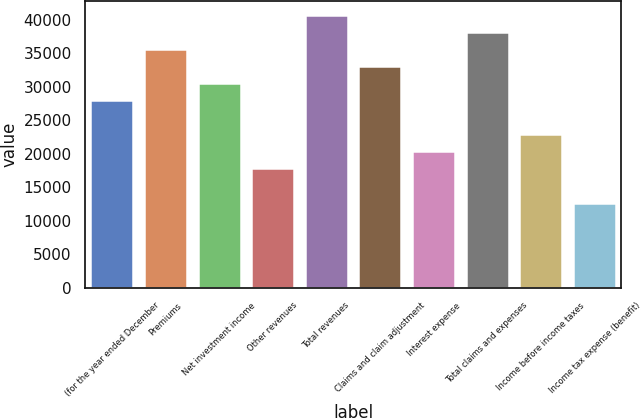Convert chart to OTSL. <chart><loc_0><loc_0><loc_500><loc_500><bar_chart><fcel>(for the year ended December<fcel>Premiums<fcel>Net investment income<fcel>Other revenues<fcel>Total revenues<fcel>Claims and claim adjustment<fcel>Interest expense<fcel>Total claims and expenses<fcel>Income before income taxes<fcel>Income tax expense (benefit)<nl><fcel>27990.5<fcel>35624<fcel>30535<fcel>17812.5<fcel>40713.1<fcel>33079.5<fcel>20357<fcel>38168.6<fcel>22901.5<fcel>12723.5<nl></chart> 